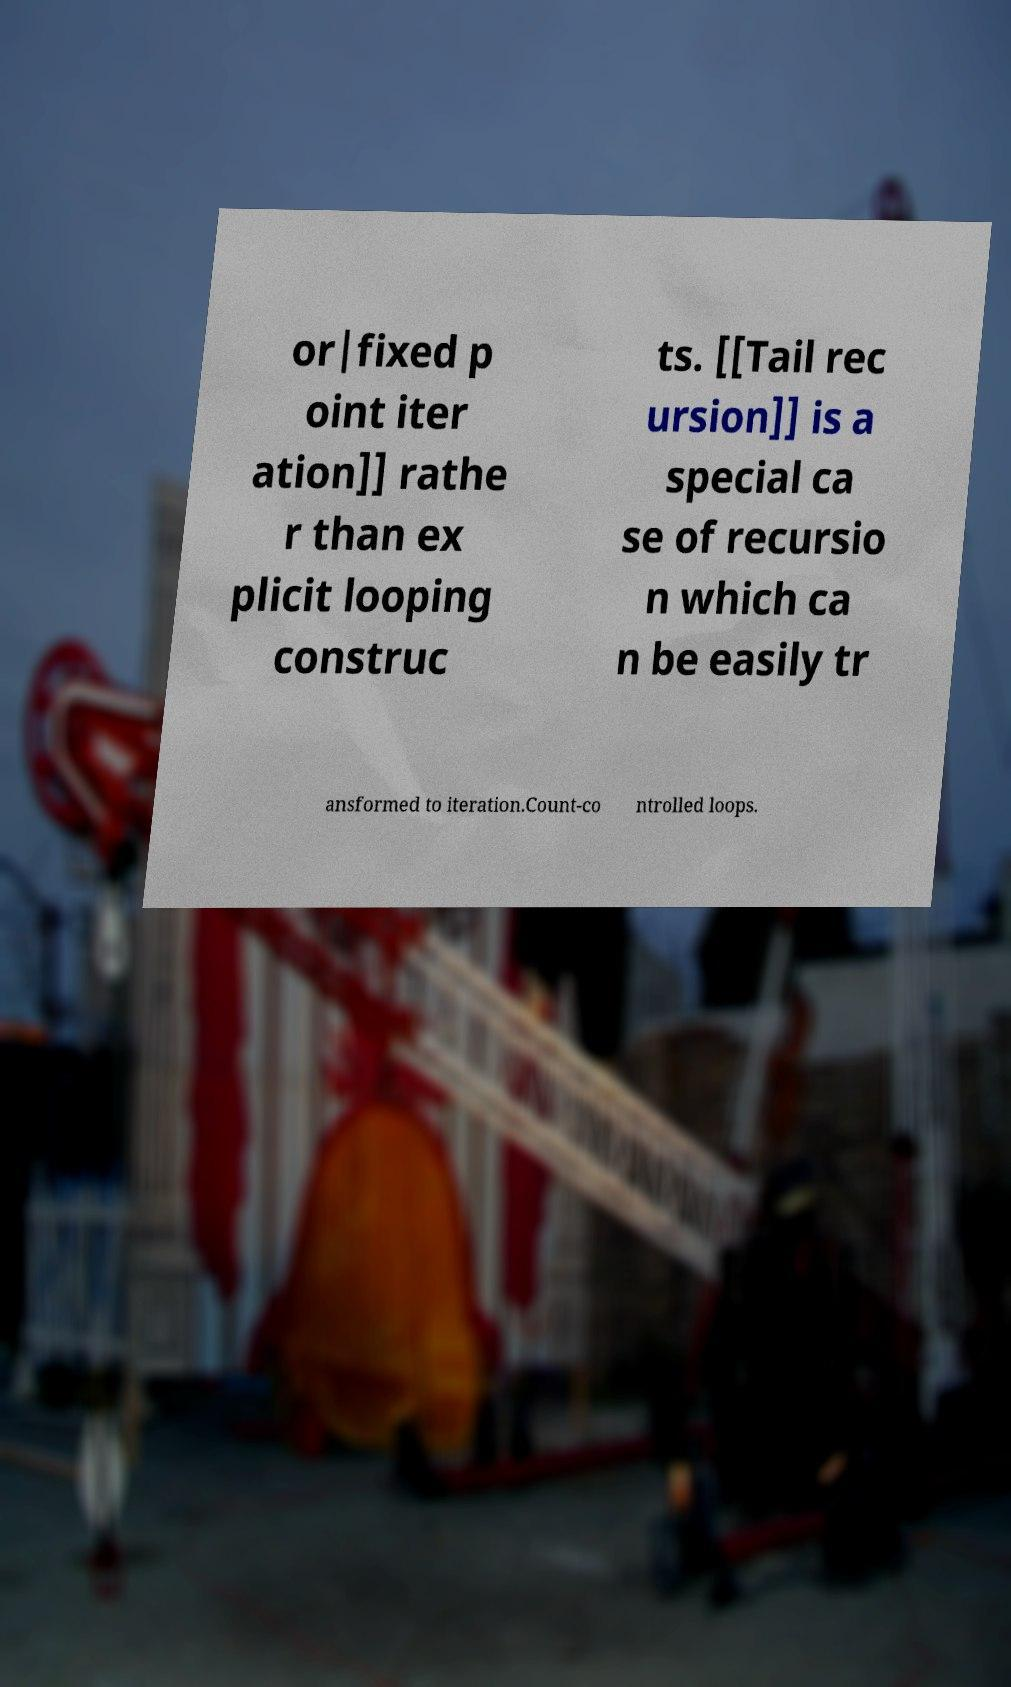What messages or text are displayed in this image? I need them in a readable, typed format. or|fixed p oint iter ation]] rathe r than ex plicit looping construc ts. [[Tail rec ursion]] is a special ca se of recursio n which ca n be easily tr ansformed to iteration.Count-co ntrolled loops. 